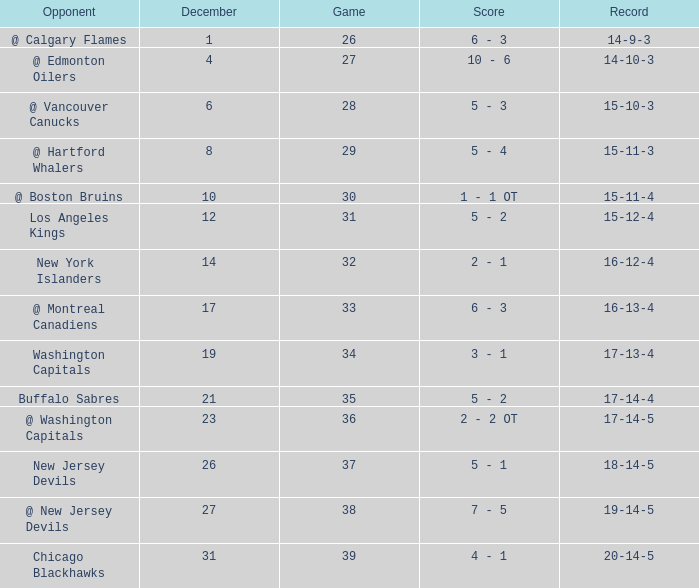Game smaller than 34, and a December smaller than 14, and a Score of 10 - 6 has what opponent? @ Edmonton Oilers. 